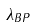Convert formula to latex. <formula><loc_0><loc_0><loc_500><loc_500>\lambda _ { B P }</formula> 